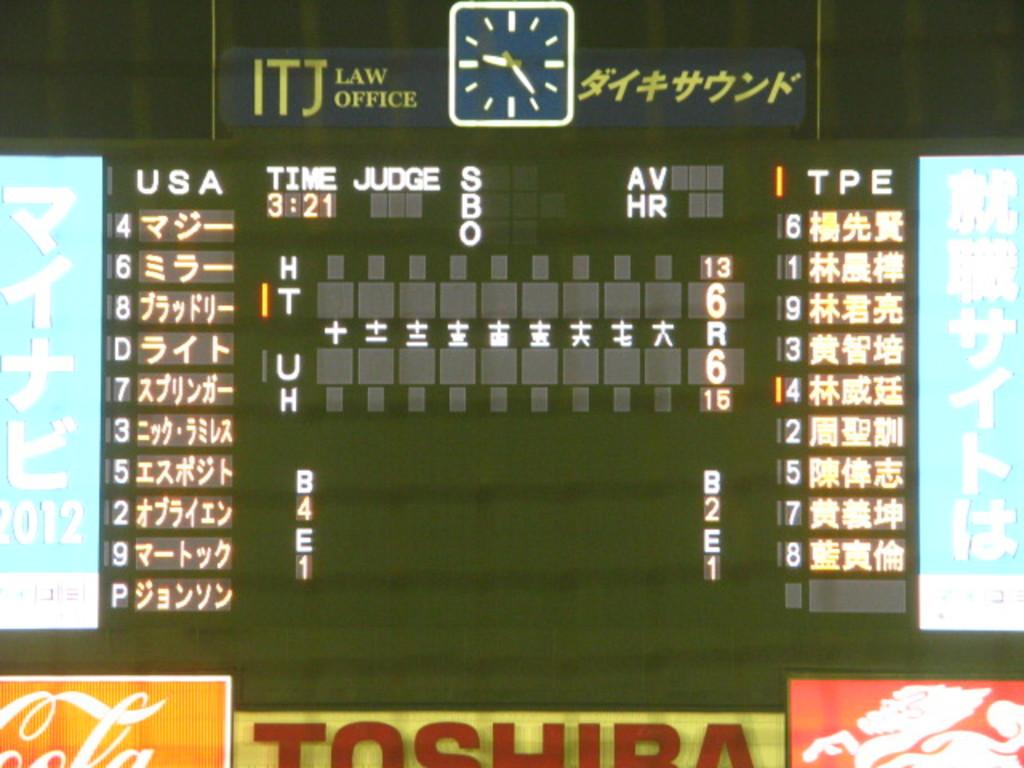What is the score?
Make the answer very short. 6-6. What time is left?
Your answer should be very brief. 3:21. 